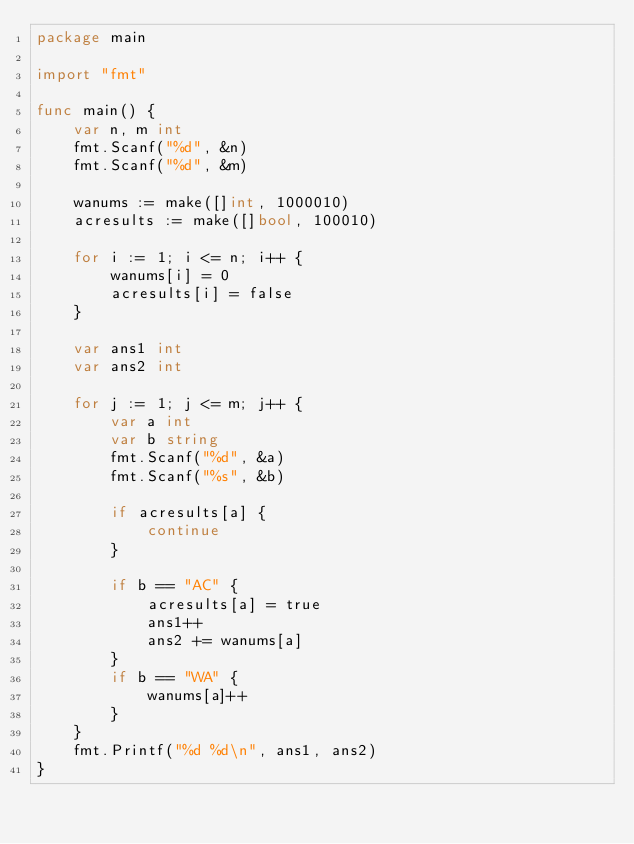Convert code to text. <code><loc_0><loc_0><loc_500><loc_500><_Go_>package main

import "fmt"

func main() {
	var n, m int
	fmt.Scanf("%d", &n)
	fmt.Scanf("%d", &m)

	wanums := make([]int, 1000010)
	acresults := make([]bool, 100010)

	for i := 1; i <= n; i++ {
		wanums[i] = 0
		acresults[i] = false
	}

	var ans1 int
	var ans2 int

	for j := 1; j <= m; j++ {
		var a int
		var b string
		fmt.Scanf("%d", &a)
		fmt.Scanf("%s", &b)

		if acresults[a] {
			continue
		}

		if b == "AC" {
			acresults[a] = true
			ans1++
			ans2 += wanums[a]
		}
		if b == "WA" {
			wanums[a]++
		}
	}
	fmt.Printf("%d %d\n", ans1, ans2)
}</code> 